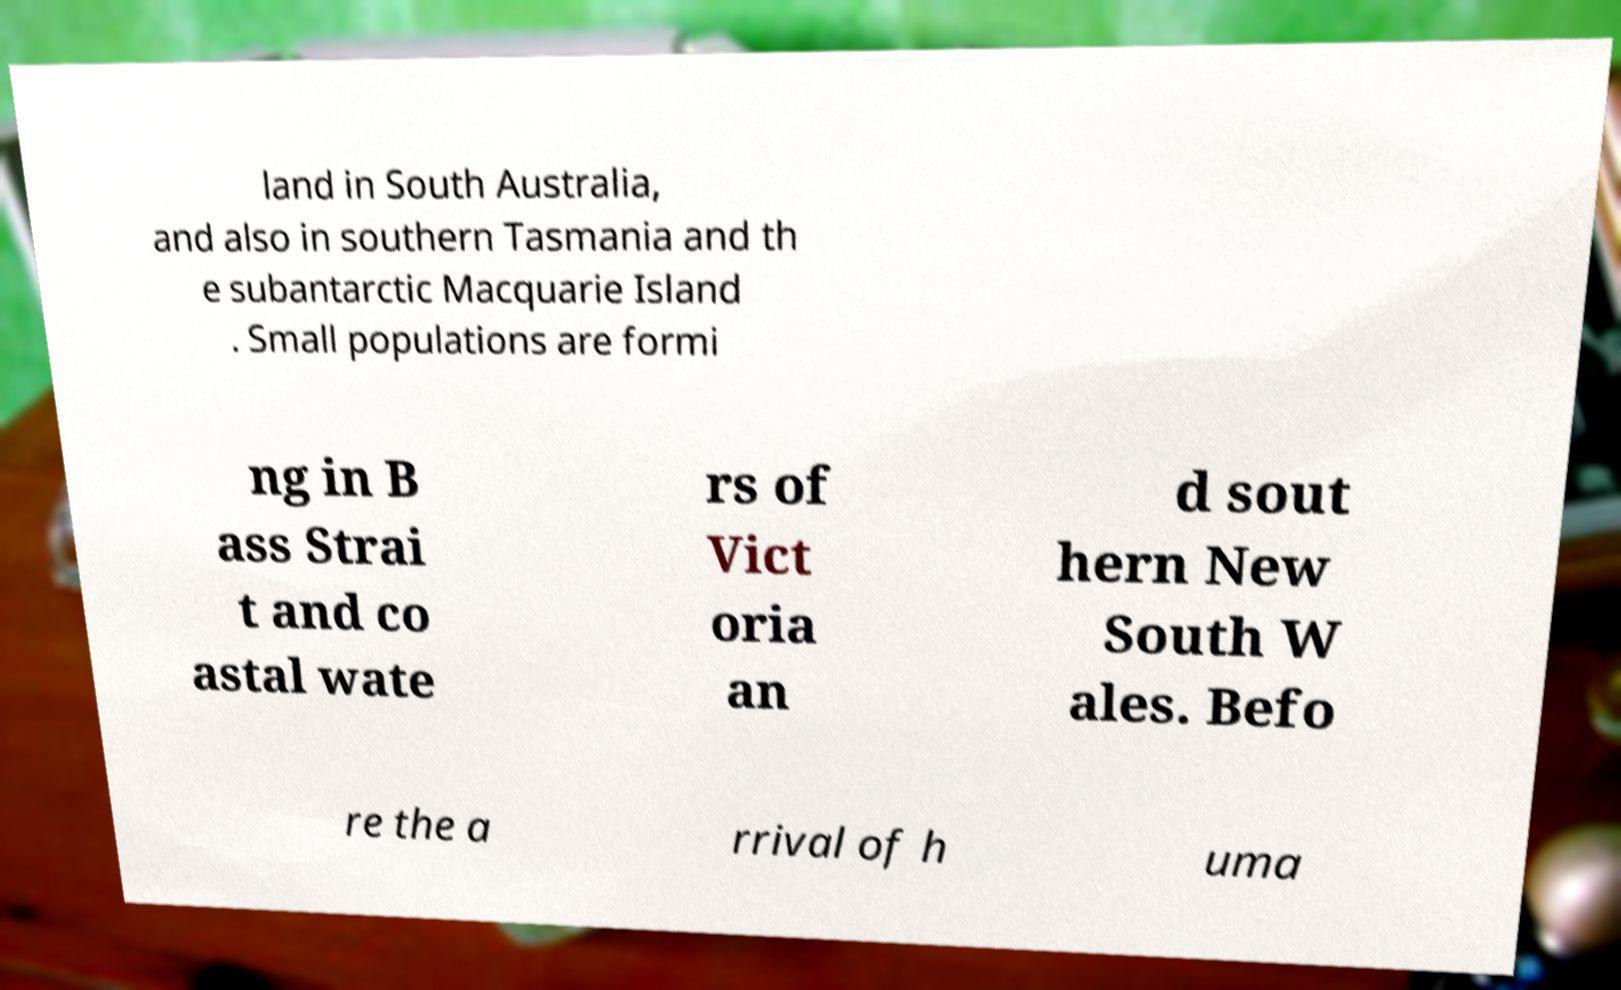Please read and relay the text visible in this image. What does it say? land in South Australia, and also in southern Tasmania and th e subantarctic Macquarie Island . Small populations are formi ng in B ass Strai t and co astal wate rs of Vict oria an d sout hern New South W ales. Befo re the a rrival of h uma 